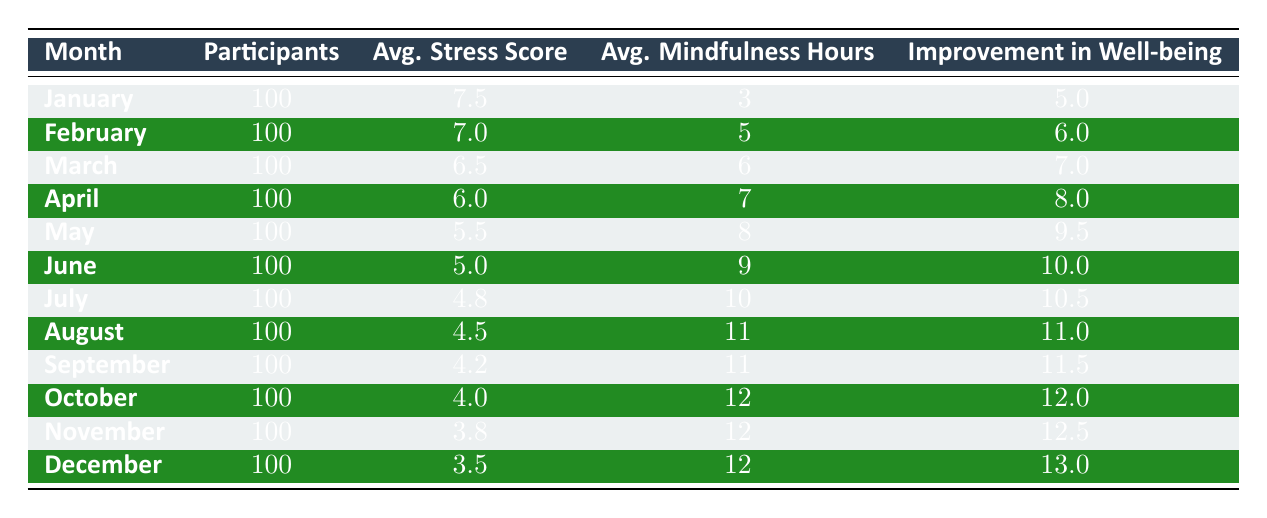What was the average stress score in December? Looking at the table, the average stress score for December is given directly. It states that the average stress score for that month is 3.5.
Answer: 3.5 How many mindfulness hours were recorded in June? The table directly lists the average mindfulness hours for each month. For June, it states that there were 9 average mindfulness hours recorded.
Answer: 9 What is the improvement in emotional well-being from January to March? To find the improvement in emotional well-being, we subtract the improvement in March (7.0) from the improvement in January (5.0). The calculation is 7.0 - 5.0 = 2.0, indicating that there was an improvement of 2.0 from January to March.
Answer: 2.0 Was the average stress score in November lower than in October? By comparing the two months in the table, the average stress score for November is 3.8, while for October it is 4.0. Since 3.8 is less than 4.0, the statement is true.
Answer: Yes What was the average improvement in emotional well-being over the last three months (October, November, December)? First, we need to find the improvements for those months: October (12.0), November (12.5), and December (13.0). Next, we sum them up: 12.0 + 12.5 + 13.0 = 37.5. Finally, we divide by the number of months (3) to get the average: 37.5 / 3 = 12.5.
Answer: 12.5 How did the average stress score change from May to August? From the table, the average stress score decreased from 5.5 in May to 4.5 in August. To find the difference, subtract the August score from the May score: 5.5 - 4.5 = 1.0. Thus, the average stress score decreased by 1.0.
Answer: 1.0 In how many months did the average mindfulness hours exceed 10? Looking at the table, the months with average mindfulness hours exceeding 10 are July (10), August (11), September (11), October (12), November (12), and December (12). That gives us a total of 6 months.
Answer: 6 What was the highest recorded average stress score throughout the year? By reviewing the average stress scores listed in the table, we see that the highest stress score is 7.5 in January.
Answer: 7.5 